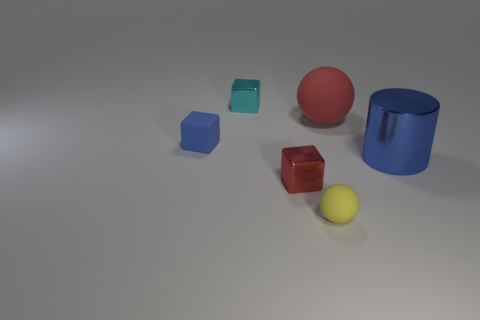Subtract all rubber cubes. How many cubes are left? 2 Add 1 big blue cylinders. How many objects exist? 7 Subtract all cylinders. How many objects are left? 5 Subtract all purple cubes. Subtract all yellow cylinders. How many cubes are left? 3 Add 2 big red cylinders. How many big red cylinders exist? 2 Subtract 0 yellow cubes. How many objects are left? 6 Subtract all large blue objects. Subtract all tiny matte objects. How many objects are left? 3 Add 2 blue cylinders. How many blue cylinders are left? 3 